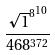Convert formula to latex. <formula><loc_0><loc_0><loc_500><loc_500>\frac { { \sqrt { 1 } ^ { 8 } } ^ { 1 0 } } { 4 6 8 ^ { 3 7 2 } }</formula> 